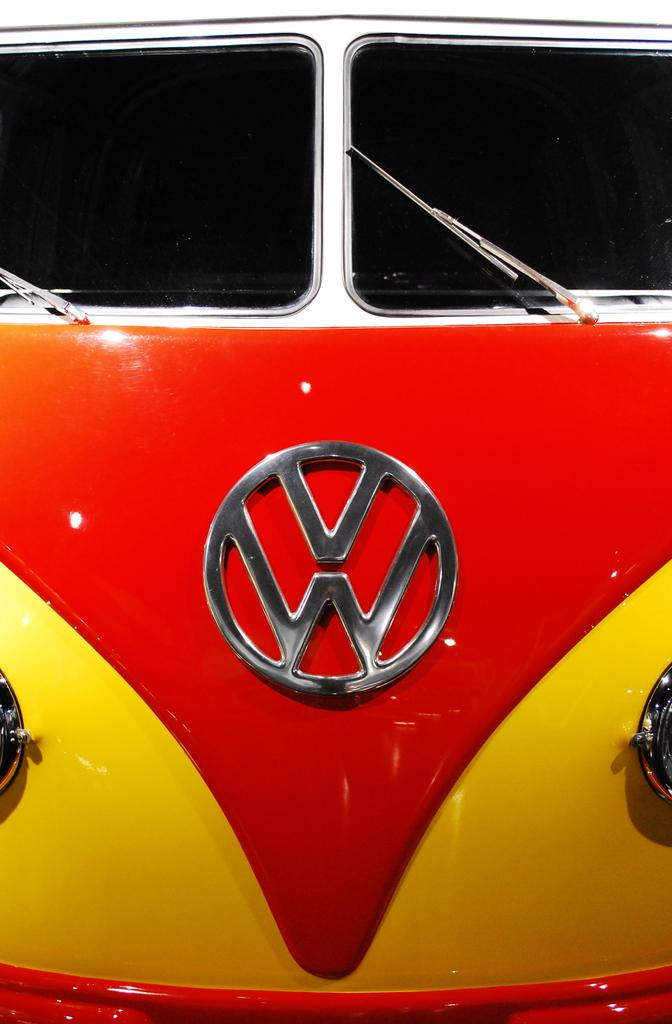What is the main subject in the image? There is a vehicle in the image. What colors can be seen on the vehicle? The vehicle has red and yellow colors. What causes the vehicle to fly in the image? The vehicle does not fly in the image; it is stationary on the ground. Is there any smoke coming out of the vehicle in the image? There is no mention of smoke in the image, so we cannot determine if it is present or not. 